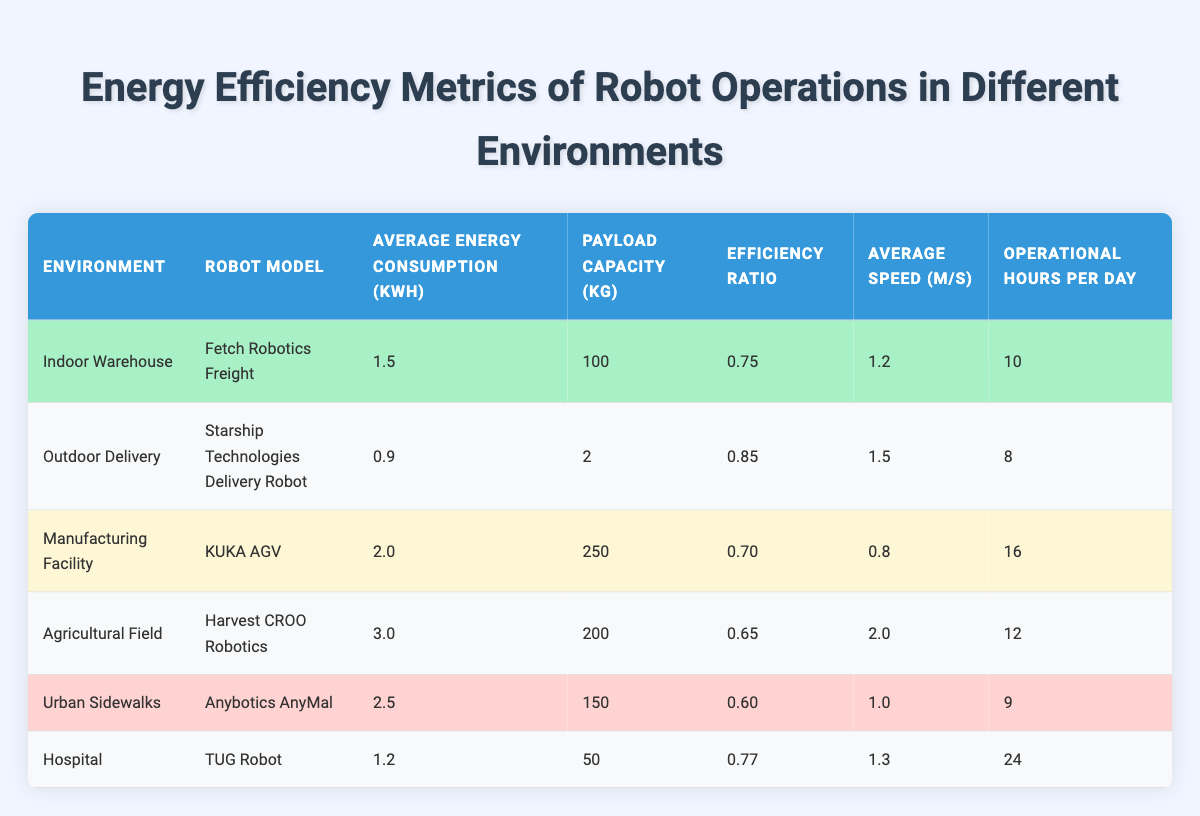What is the average energy consumption of the robot operating in the Outdoor Delivery environment? According to the table, the Average Energy Consumption for the Outdoor Delivery is 0.9 kWh.
Answer: 0.9 kWh Which robot has the highest payload capacity and how much is it? The robot with the highest payload capacity is the KUKA AGV, with a capacity of 250 kg.
Answer: 250 kg True or False: The robot operating in the Agricultural Field has an efficiency ratio higher than 0.7. The Efficiency Ratio for the Harvest CROO Robotics operating in the Agricultural Field is 0.65, which is less than 0.7. Hence, the statement is false.
Answer: False What is the sum of operational hours per day for all robots in the table? Adding the operational hours from the table: 10 (Indoor Warehouse) + 8 (Outdoor Delivery) + 16 (Manufacturing Facility) + 12 (Agricultural Field) + 9 (Urban Sidewalks) + 24 (Hospital) gives a total of 79 operational hours per day.
Answer: 79 hours Which environment has the robot with the second highest efficiency ratio, and what is that ratio? The Outdoor Delivery environment has the second highest efficiency ratio of 0.85 (for the Starship Technologies Delivery Robot), whereas the highest ratio is 0.85. It is the same as the highest one.
Answer: Outdoor Delivery, 0.85 How much more energy does the Harvest CROO Robotics consume compared to the Starship Technologies Delivery Robot? The Average Energy Consumption for Harvest CROO Robotics is 3.0 kWh and for Starship Technologies it's 0.9 kWh. The difference is 3.0 - 0.9 = 2.1 kWh.
Answer: 2.1 kWh What is the average speed of robots operating in environments with an efficiency ratio below 0.7? The robots with an efficiency ratio below 0.7 are: KUKA AGV (0.70), Harvest CROO Robotics (0.65), and Anybotics AnyMal (0.60). Their average speeds are 0.8 m/s, 2.0 m/s, and 1.0 m/s respectively. Average speed = (0.8 + 2.0 + 1.0) / 3 = 1.267 m/s (approximately 1.27 m/s).
Answer: 1.27 m/s Which robot operates the longest hours per day and what is the environment it operates in? The TUG Robot operates for 24 hours per day in the Hospital environment, which is the longest compared to others.
Answer: Hospital, 24 hours Is there a robot that meets or exceeds a payload capacity of 200 kg? Yes, the KUKA AGV has a payload capacity of 250 kg, and the Harvest CROO Robotics has a payload capacity of 200 kg.
Answer: Yes What is the average efficiency ratio of all the robots listed in the table? The efficiency ratios are 0.75 (Indoor Warehouse), 0.85 (Outdoor Delivery), 0.70 (Manufacturing Facility), 0.65 (Agricultural Field), 0.60 (Urban Sidewalks), and 0.77 (Hospital). To find the average: (0.75 + 0.85 + 0.70 + 0.65 + 0.60 + 0.77) / 6 = 0.720833, which is approximately 0.72.
Answer: 0.72 